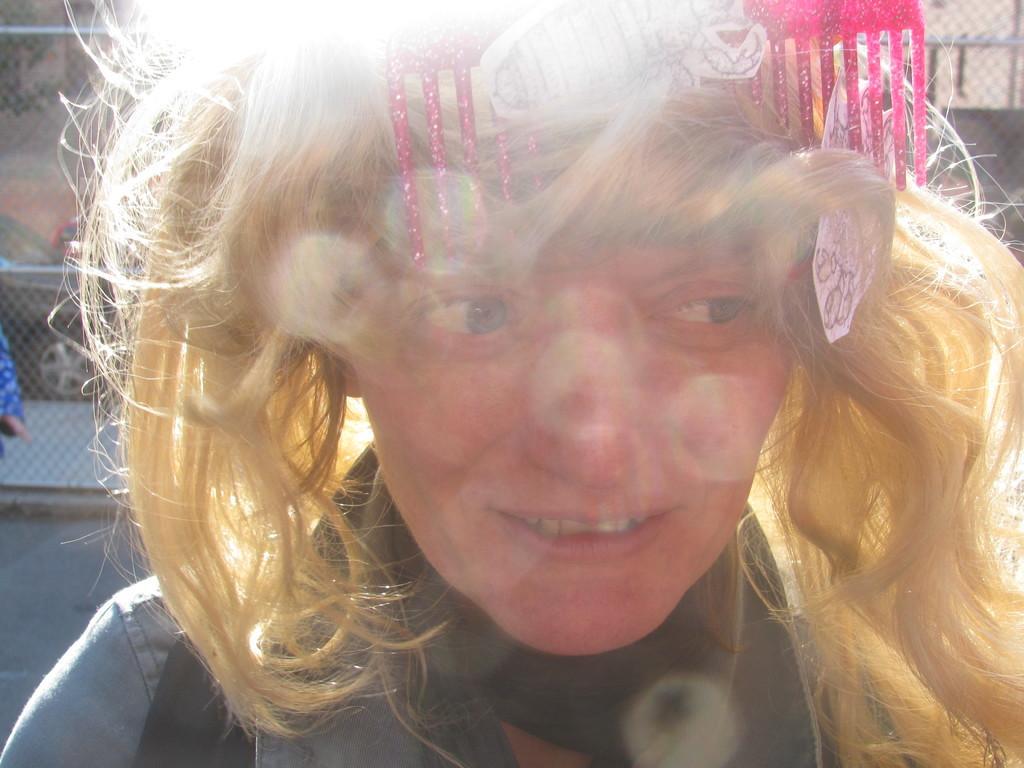Can you describe this image briefly? In the picture I can see a woman who is wearing a comb on her head and some other objects. In the background I can see fence and some other objects. 